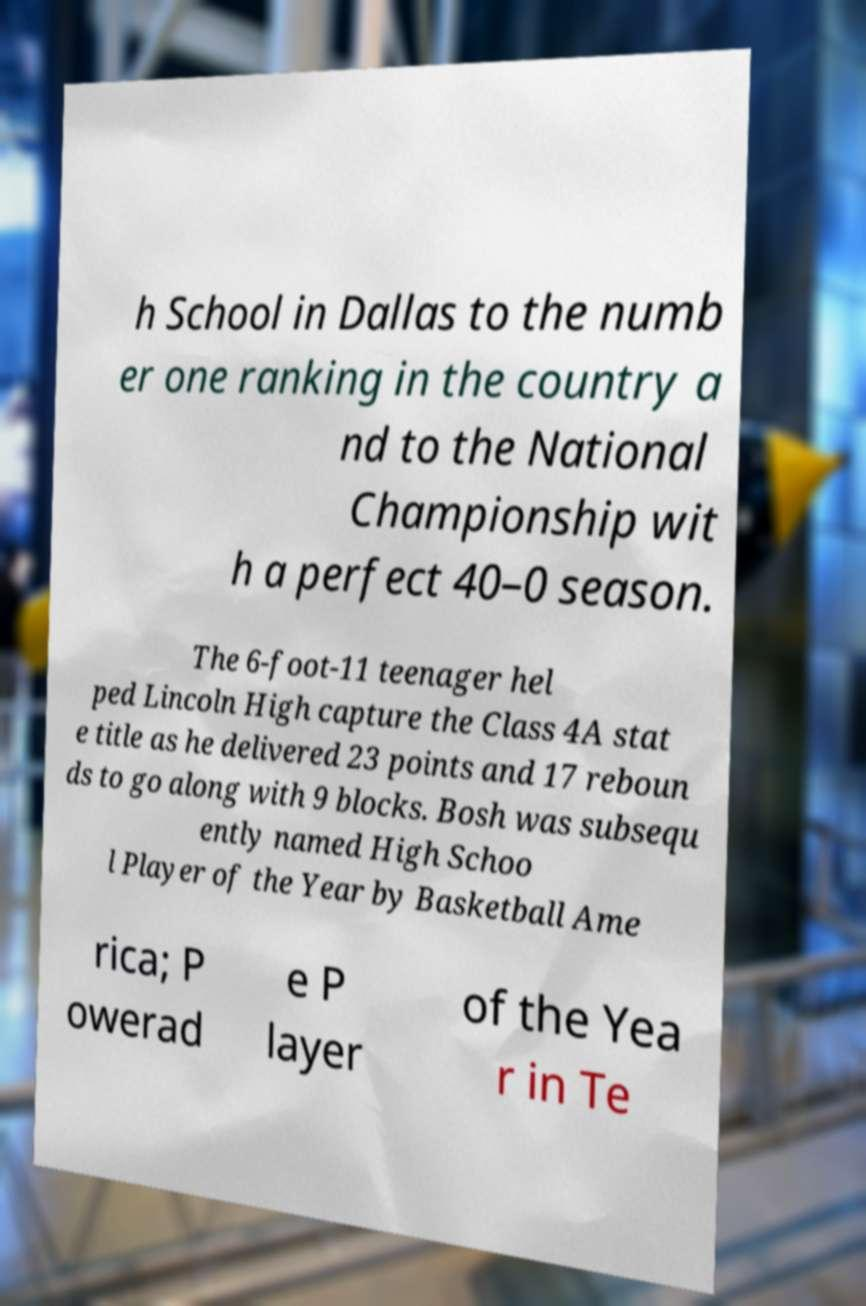What messages or text are displayed in this image? I need them in a readable, typed format. h School in Dallas to the numb er one ranking in the country a nd to the National Championship wit h a perfect 40–0 season. The 6-foot-11 teenager hel ped Lincoln High capture the Class 4A stat e title as he delivered 23 points and 17 reboun ds to go along with 9 blocks. Bosh was subsequ ently named High Schoo l Player of the Year by Basketball Ame rica; P owerad e P layer of the Yea r in Te 